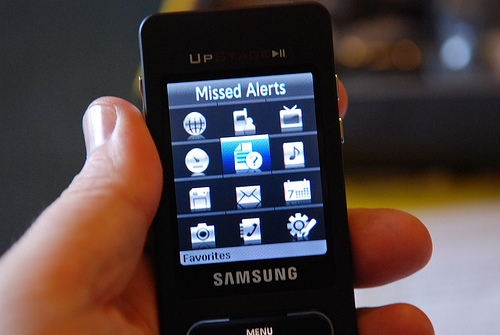What features can you identify on the phone's screen? The phone's screen displays several icons indicating features such as 'Missed Alerts', 'Messages', 'Call History', and 'Contacts'. There are also icons for 'Camera', 'Photos', 'Settings', and 'Calendar', among others, which were common functions on feature phones. 